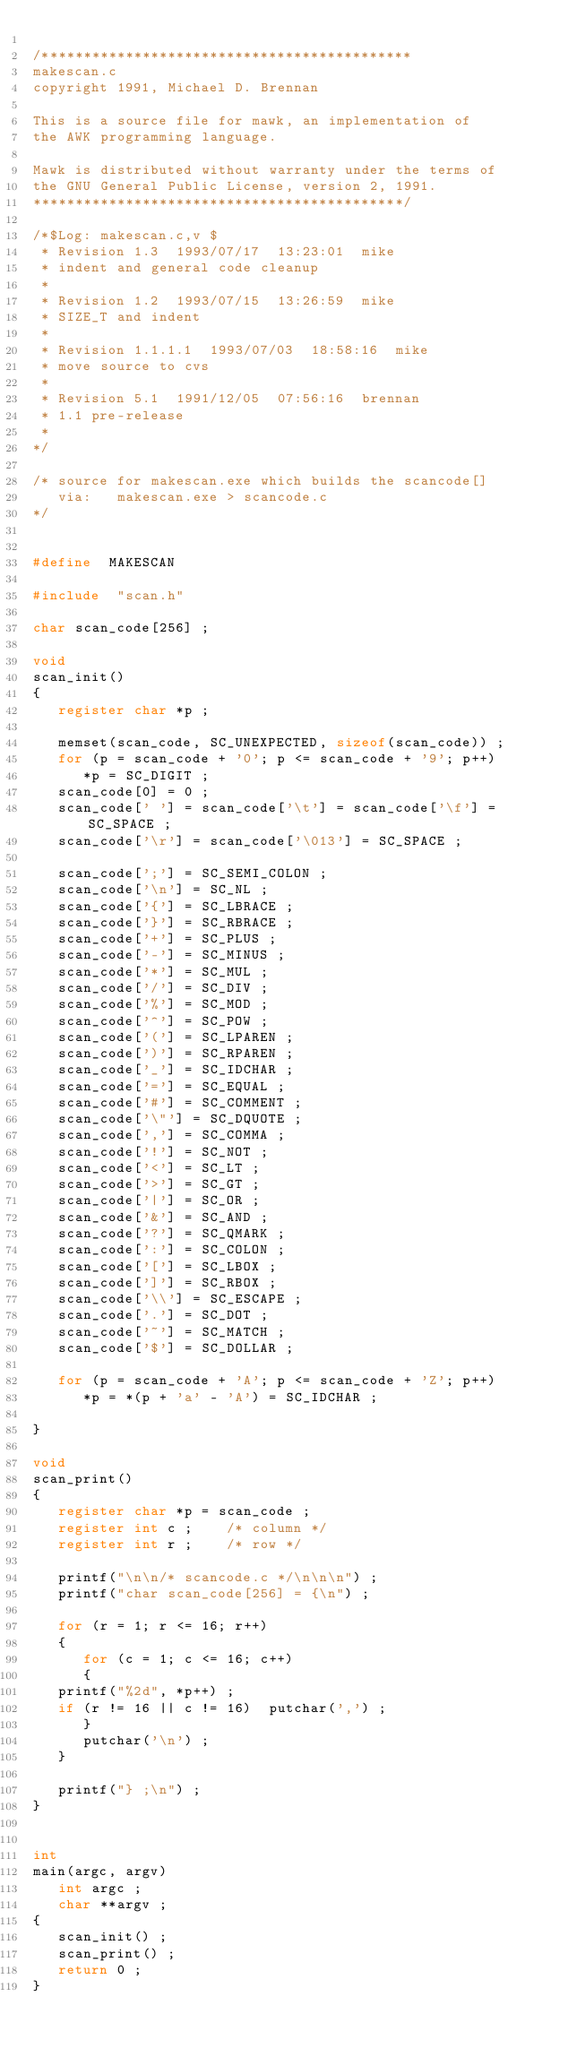<code> <loc_0><loc_0><loc_500><loc_500><_C_>
/********************************************
makescan.c
copyright 1991, Michael D. Brennan

This is a source file for mawk, an implementation of
the AWK programming language.

Mawk is distributed without warranty under the terms of
the GNU General Public License, version 2, 1991.
********************************************/

/*$Log: makescan.c,v $
 * Revision 1.3  1993/07/17  13:23:01  mike
 * indent and general code cleanup
 *
 * Revision 1.2	 1993/07/15  13:26:59  mike
 * SIZE_T and indent
 *
 * Revision 1.1.1.1  1993/07/03	 18:58:16  mike
 * move source to cvs
 *
 * Revision 5.1	 1991/12/05  07:56:16  brennan
 * 1.1 pre-release
 *
*/

/* source for makescan.exe which builds the scancode[]
   via:	  makescan.exe > scancode.c
*/


#define	 MAKESCAN

#include  "scan.h"

char scan_code[256] ;

void
scan_init()
{
   register char *p ;

   memset(scan_code, SC_UNEXPECTED, sizeof(scan_code)) ;
   for (p = scan_code + '0'; p <= scan_code + '9'; p++)
      *p = SC_DIGIT ;
   scan_code[0] = 0 ;
   scan_code[' '] = scan_code['\t'] = scan_code['\f'] = SC_SPACE ;
   scan_code['\r'] = scan_code['\013'] = SC_SPACE ;

   scan_code[';'] = SC_SEMI_COLON ;
   scan_code['\n'] = SC_NL ;
   scan_code['{'] = SC_LBRACE ;
   scan_code['}'] = SC_RBRACE ;
   scan_code['+'] = SC_PLUS ;
   scan_code['-'] = SC_MINUS ;
   scan_code['*'] = SC_MUL ;
   scan_code['/'] = SC_DIV ;
   scan_code['%'] = SC_MOD ;
   scan_code['^'] = SC_POW ;
   scan_code['('] = SC_LPAREN ;
   scan_code[')'] = SC_RPAREN ;
   scan_code['_'] = SC_IDCHAR ;
   scan_code['='] = SC_EQUAL ;
   scan_code['#'] = SC_COMMENT ;
   scan_code['\"'] = SC_DQUOTE ;
   scan_code[','] = SC_COMMA ;
   scan_code['!'] = SC_NOT ;
   scan_code['<'] = SC_LT ;
   scan_code['>'] = SC_GT ;
   scan_code['|'] = SC_OR ;
   scan_code['&'] = SC_AND ;
   scan_code['?'] = SC_QMARK ;
   scan_code[':'] = SC_COLON ;
   scan_code['['] = SC_LBOX ;
   scan_code[']'] = SC_RBOX ;
   scan_code['\\'] = SC_ESCAPE ;
   scan_code['.'] = SC_DOT ;
   scan_code['~'] = SC_MATCH ;
   scan_code['$'] = SC_DOLLAR ;

   for (p = scan_code + 'A'; p <= scan_code + 'Z'; p++)
      *p = *(p + 'a' - 'A') = SC_IDCHAR ;

}

void
scan_print()
{
   register char *p = scan_code ;
   register int c ;		 /* column */
   register int r ;		 /* row */

   printf("\n\n/* scancode.c */\n\n\n") ;
   printf("char scan_code[256] = {\n") ;

   for (r = 1; r <= 16; r++)
   {
      for (c = 1; c <= 16; c++)
      {
	 printf("%2d", *p++) ;
	 if (r != 16 || c != 16)  putchar(',') ;
      }
      putchar('\n') ;
   }

   printf("} ;\n") ;
}


int
main(argc, argv)
   int argc ;
   char **argv ;
{
   scan_init() ;
   scan_print() ;
   return 0 ;
}
</code> 